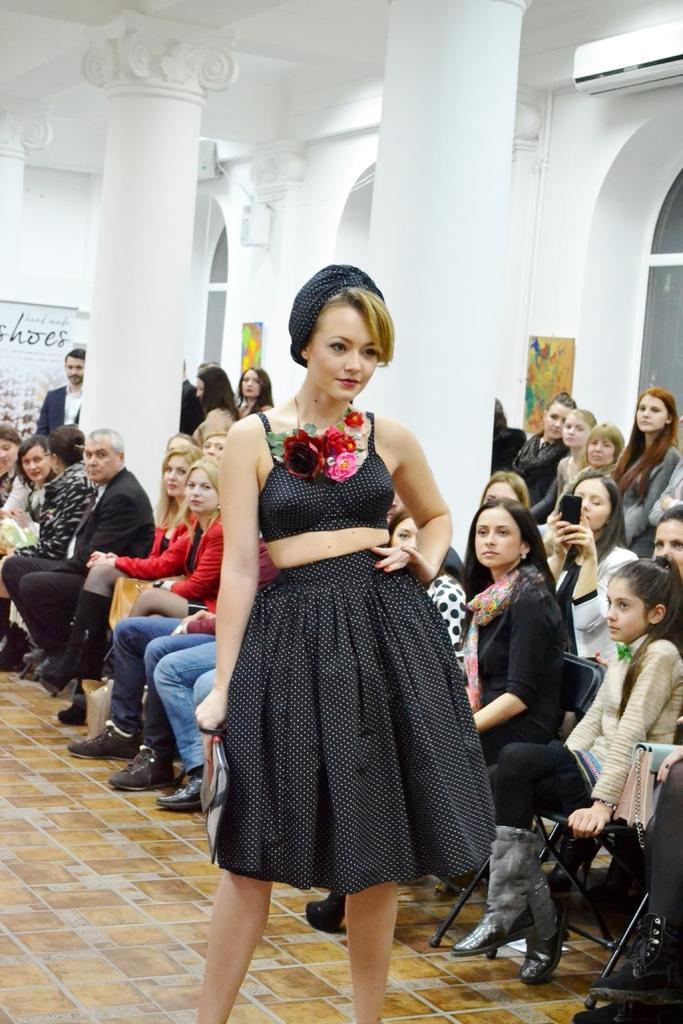Please provide a concise description of this image. In this picture we can observe a woman standing on the floor. She is wearing black color dress and smiling. Behind her there are some people sitting in the chairs. There are men and women. Some of them were standing. We can observe two white color pillars. In the background there is a wall. 